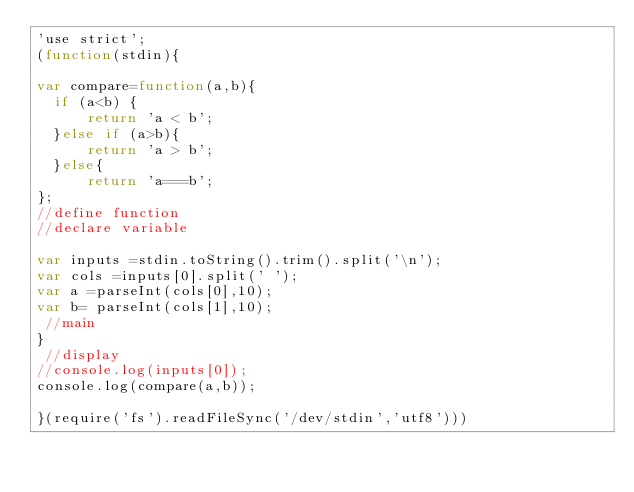<code> <loc_0><loc_0><loc_500><loc_500><_JavaScript_>'use strict';
(function(stdin){

var compare=function(a,b){
  if (a<b) {
      return 'a < b';
  }else if (a>b){
      return 'a > b';
  }else{
      return 'a===b';
};
//define function
//declare variable

var inputs =stdin.toString().trim().split('\n');
var cols =inputs[0].split(' ');
var a =parseInt(cols[0],10);
var b= parseInt(cols[1],10);
 //main
}
 //display
//console.log(inputs[0]);
console.log(compare(a,b));

}(require('fs').readFileSync('/dev/stdin','utf8')))</code> 